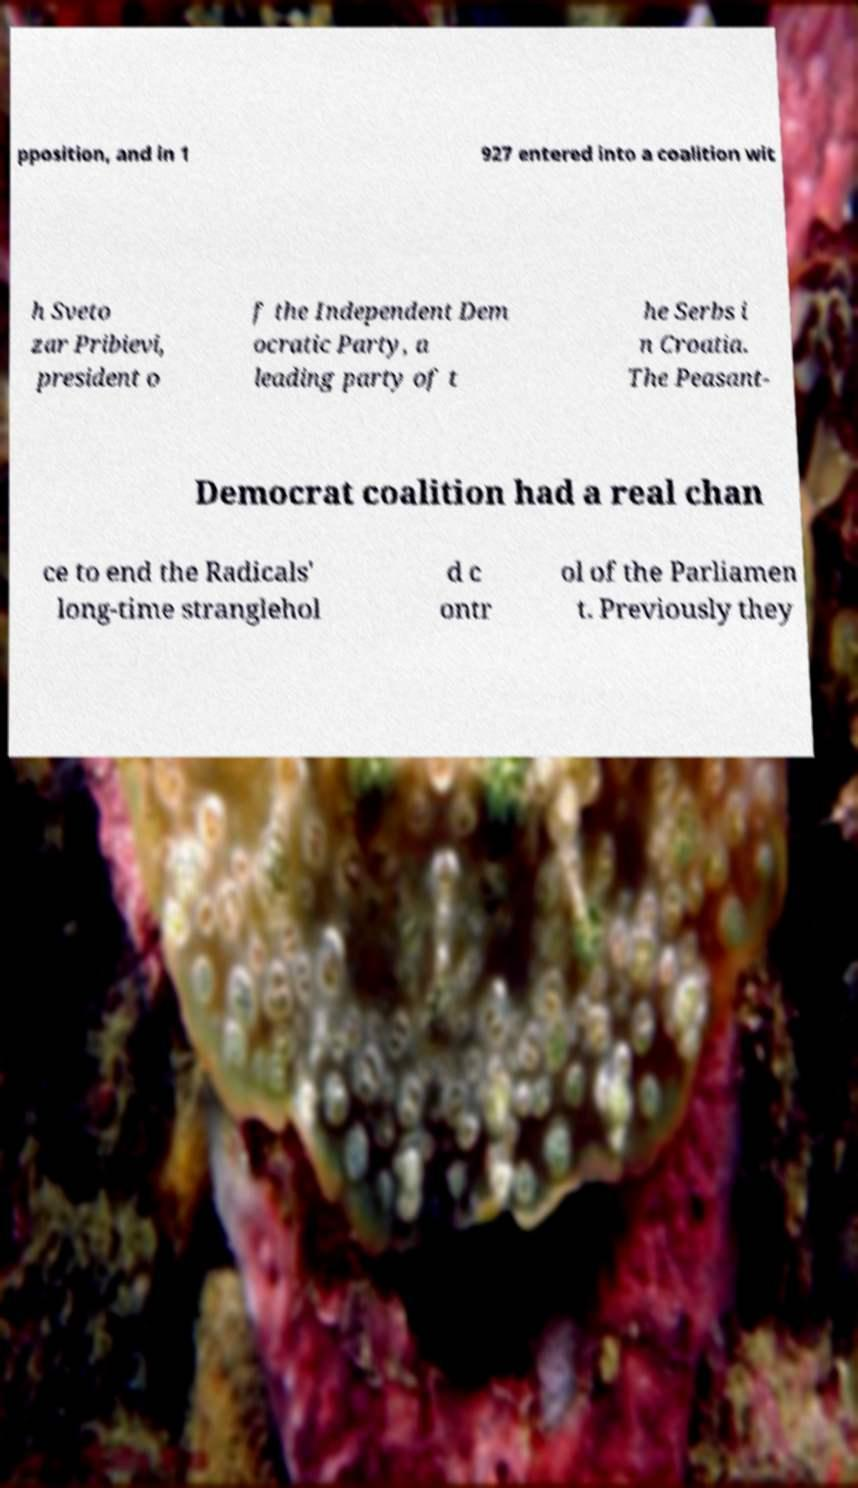There's text embedded in this image that I need extracted. Can you transcribe it verbatim? pposition, and in 1 927 entered into a coalition wit h Sveto zar Pribievi, president o f the Independent Dem ocratic Party, a leading party of t he Serbs i n Croatia. The Peasant- Democrat coalition had a real chan ce to end the Radicals' long-time stranglehol d c ontr ol of the Parliamen t. Previously they 